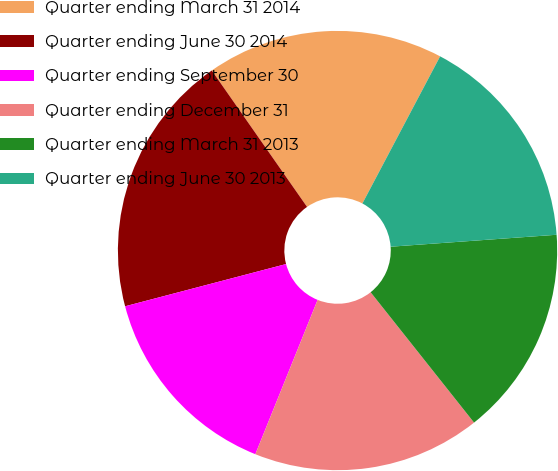Convert chart to OTSL. <chart><loc_0><loc_0><loc_500><loc_500><pie_chart><fcel>Quarter ending March 31 2014<fcel>Quarter ending June 30 2014<fcel>Quarter ending September 30<fcel>Quarter ending December 31<fcel>Quarter ending March 31 2013<fcel>Quarter ending June 30 2013<nl><fcel>17.44%<fcel>19.38%<fcel>14.81%<fcel>16.78%<fcel>15.47%<fcel>16.12%<nl></chart> 